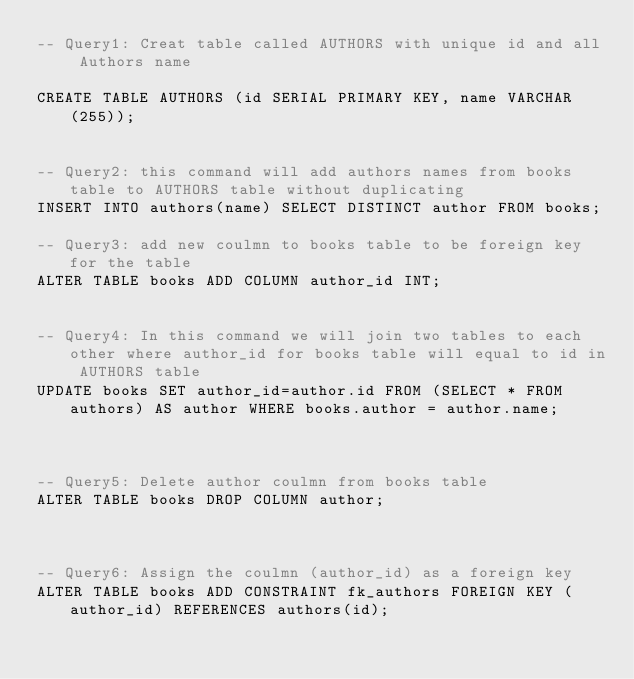<code> <loc_0><loc_0><loc_500><loc_500><_SQL_>-- Query1: Creat table called AUTHORS with unique id and all Authors name 

CREATE TABLE AUTHORS (id SERIAL PRIMARY KEY, name VARCHAR(255));


-- Query2: this command will add authors names from books table to AUTHORS table without duplicating 
INSERT INTO authors(name) SELECT DISTINCT author FROM books;

-- Query3: add new coulmn to books table to be foreign key for the table
ALTER TABLE books ADD COLUMN author_id INT;


-- Query4: In this command we will join two tables to each other where author_id for books table will equal to id in AUTHORS table
UPDATE books SET author_id=author.id FROM (SELECT * FROM authors) AS author WHERE books.author = author.name;



-- Query5: Delete author coulmn from books table 
ALTER TABLE books DROP COLUMN author;



-- Query6: Assign the coulmn (author_id) as a foreign key
ALTER TABLE books ADD CONSTRAINT fk_authors FOREIGN KEY (author_id) REFERENCES authors(id);</code> 